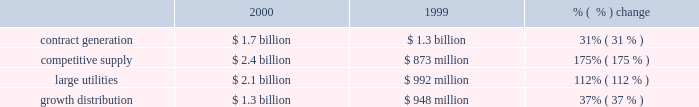Wrote-off debt issuance costs of $ 4 million , which resulted in an extraordinary loss for the early retirement of debt .
Net income net income decreased $ 522 million to $ 273 million in 2001 from $ 795 million in 2000 .
The overall decrease in net income is due to decreased net income from competitive supply and large utility businesses offset slightly by increases in the contract generation and growth distribution businesses .
The decreases are primarily due to lower market prices in the united kingdom and the decline in the brazilian real during 2001 resulting in foreign currency transaction losses of approximately $ 210 million .
Additionally the company recorded severance and transaction costs related to the ipalco pooling-of-interest transaction and a loss from discontinued operations of $ 194 million .
Our 10 largest contributors to net income in 2001 were as follows : lal pir/pak gen , shady point and thames from contract generation ; somerset from competitive supply ; edc , eletropaulo , ipalco , cilcorp and cemig from large utilities ; and sul from growth distribution .
2000 compared to 1999 revenues revenues increased $ 3.4 billion , or 83% ( 83 % ) , to $ 7.5 billion in 2000 from $ 4.1 billion in 1999 .
The increase in revenues is due primarily to the acquisition of new businesses .
Excluding businesses acquired or that commenced commercial operations during 2000 or 1999 , revenues increased 6% ( 6 % ) to $ 3.6 billion. .
Contract generation revenues increased $ 400 million , or 31% ( 31 % ) , to $ 1.7 billion in 2000 from $ 1.3 billion in 1999 .
Excluding businesses acquired or that commenced commercial operations in 2000 or 1999 , contract generation revenues increased 4% ( 4 % ) to $ 1.3 billion in 2000 .
The increase in contract generation segment revenues was due primarily to increases in south america , north america , caribbean and asia , offset by a slight decline in europe/africa .
In south america , contract generation segment revenue increased $ 245 million , and this is due mainly to the acquisition of tiete .
In north america , contract generation segment revenues increased $ 76 million due primarily to the start of commercial operations at warrior run in january 2000 .
In the caribbean , contract generation segment revenues increased $ 92 million due primarily to the start of commercial operations at merida iii in june 2000 and increased revenues from los mina .
In asia , contract generation segment revenue increased $ 41 million due primarily to increased operations at the ecogen peaking plant and lal pir and pak gen in pakistan .
In europe/africa , contract generation segment revenues remained fairly constant with decreases at tisza ii in hungary being offset by the acquisition of a controlling interest at kilroot .
Competitive supply revenues increased $ 1.5 billion , or 175% ( 175 % ) , to $ 2.4 billion in 2000 from $ 873 million in 1999 .
Excluding businesses acquired or that commenced commercial operations in 2000 or 1999 , competitive supply revenues increased 25% ( 25 % ) to $ 477 million in 2000 .
The most significant increases occurred within north america and europe/africa .
Slight increases occurred in south america and the caribbean .
Asia reported a slight decrease .
In north america , competitive supply segment revenues increased $ 610 million due primarily to the new york plants and new energy .
Without the new york plants and new energy changes , what would 2000 competitive supply segment revenues have been in billions? 
Computations: (2.4 - (610 / 1000))
Answer: 1.79. 